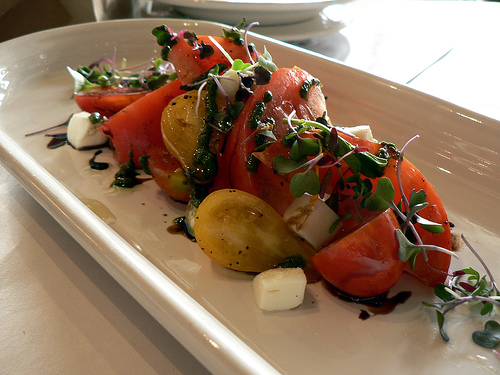<image>
Can you confirm if the plate is to the left of the food? No. The plate is not to the left of the food. From this viewpoint, they have a different horizontal relationship. Is there a parsley in front of the plates? No. The parsley is not in front of the plates. The spatial positioning shows a different relationship between these objects. 